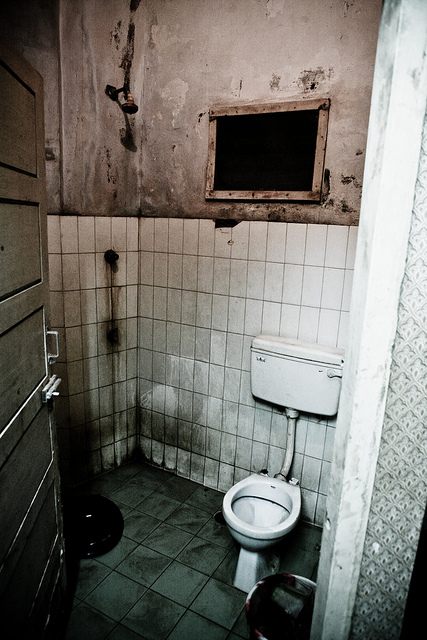<image>What is the largest diagonal visible on the wall next to the door? It is unknown what the largest diagonal visible on the wall next to the door is. It could be a window, a mirror, or tiles. The image is needed for the exact answer. What is the largest diagonal visible on the wall next to the door? I don't know what is the largest diagonal visible on the wall next to the door. It could be a window, a mirror, or something else. 